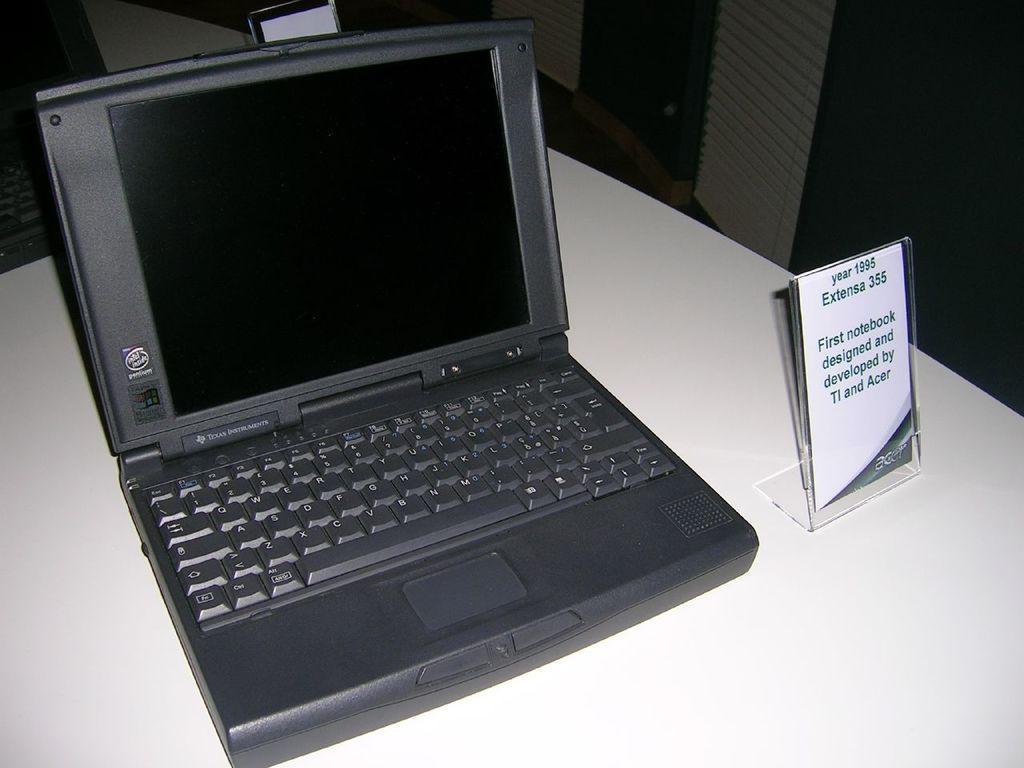Could you give a brief overview of what you see in this image? In this image we can see a laptop and a name plate is kept on white surface. 